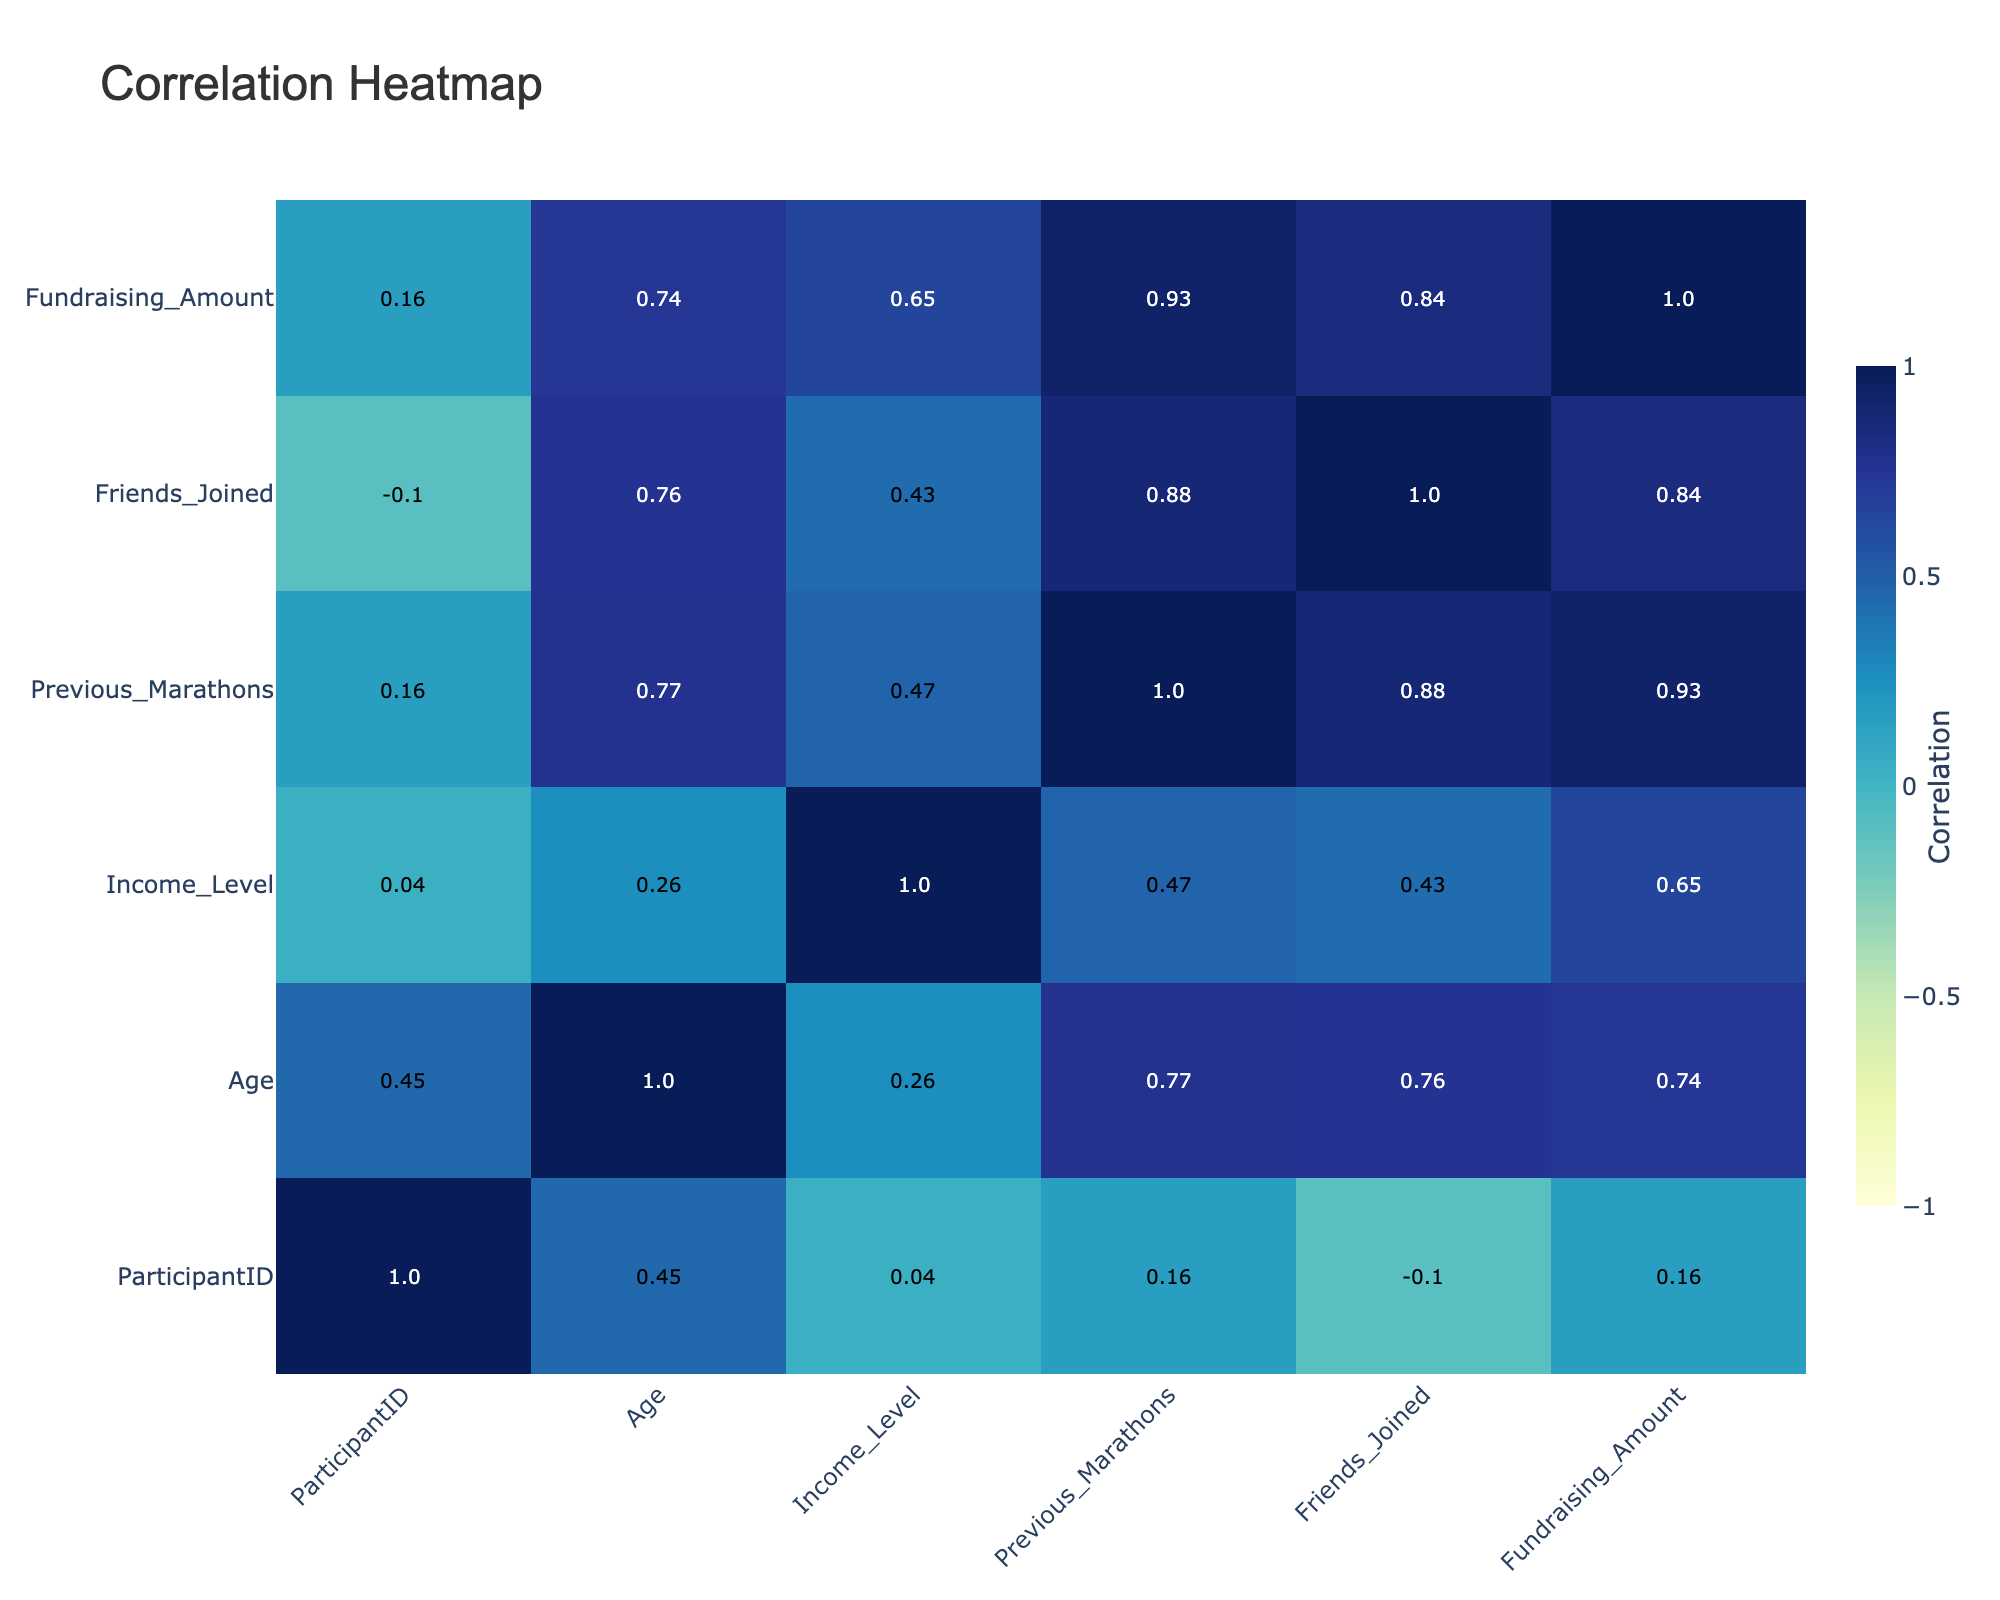What is the highest fundraising amount recorded in the table? The highest fundraising amount is 5000, found in the row with ParticipantID 6, who is an Executive with an income level of 120000.
Answer: 5000 What is the average income level of participants who have participated in more than 5 marathons? There is only one participant in this category (ParticipantID 6, Income Level 120000). Thus, the average income level is equal to that participant's income level, which is 120000.
Answer: 120000 Is there a correlation between age and fundraising amount? The correlation value between age and fundraising amount is 0.35, indicating a weak positive correlation; as age increases, fundraising amount tends to increase slightly, but the relationship is not strong.
Answer: No Do participants with more friends joining tend to raise higher amounts? Yes, there is a positive correlation of 0.38 between the number of friends joined and the fundraising amount, indicating that participants with more friends joining tend to raise a higher amount of funds.
Answer: Yes What is the total fundraising amount raised by participants who are Male? The total fundraising amounts for the Male participants (IDs 1, 4, 6, 8, and 10) are: 1500 + 1200 + 5000 + 1800 + 2600 = 12100; thus, the total fundraising amount raised by Male participants is 12100.
Answer: 12100 Is it true that all participants with an income level lower than 50000 raised less than 2000? Examining the participants with income levels lower than 50000 (IDs 2 and 7), we find that ParticipantID 2 raised 800 and ParticipantID 7 raised 250, both of which are indeed below 2000. Therefore, the statement is true.
Answer: Yes What is the average fundraising amount among participants who have run at least 4 previous marathons? The relevant participants are IDs 3, 5, and 6. Their fundraising amounts are 2000, 3000, and 5000, respectively. The average is calculated as (2000 + 3000 + 5000) / 3 = 3333.33; hence, the average fundraising amount is approximately 3333.33.
Answer: 3333.33 Does the data suggest that older participants tend to have run more previous marathons? There is a correlation coefficient of 0.57 between age and previous marathons, indicating a moderate positive correlation; this suggests that older participants tend to have participated in more previous marathons.
Answer: Yes What percentage of female participants raised more than 2000? There are 3 female participants (IDs 2, 3, and 5). Out of these, ParticipantID 5 raised 3000, which is greater than 2000. So, 1 out of 3 female participants raised more than 2000, giving us a percentage of (1/3)*100 = 33.33%.
Answer: 33.33% 